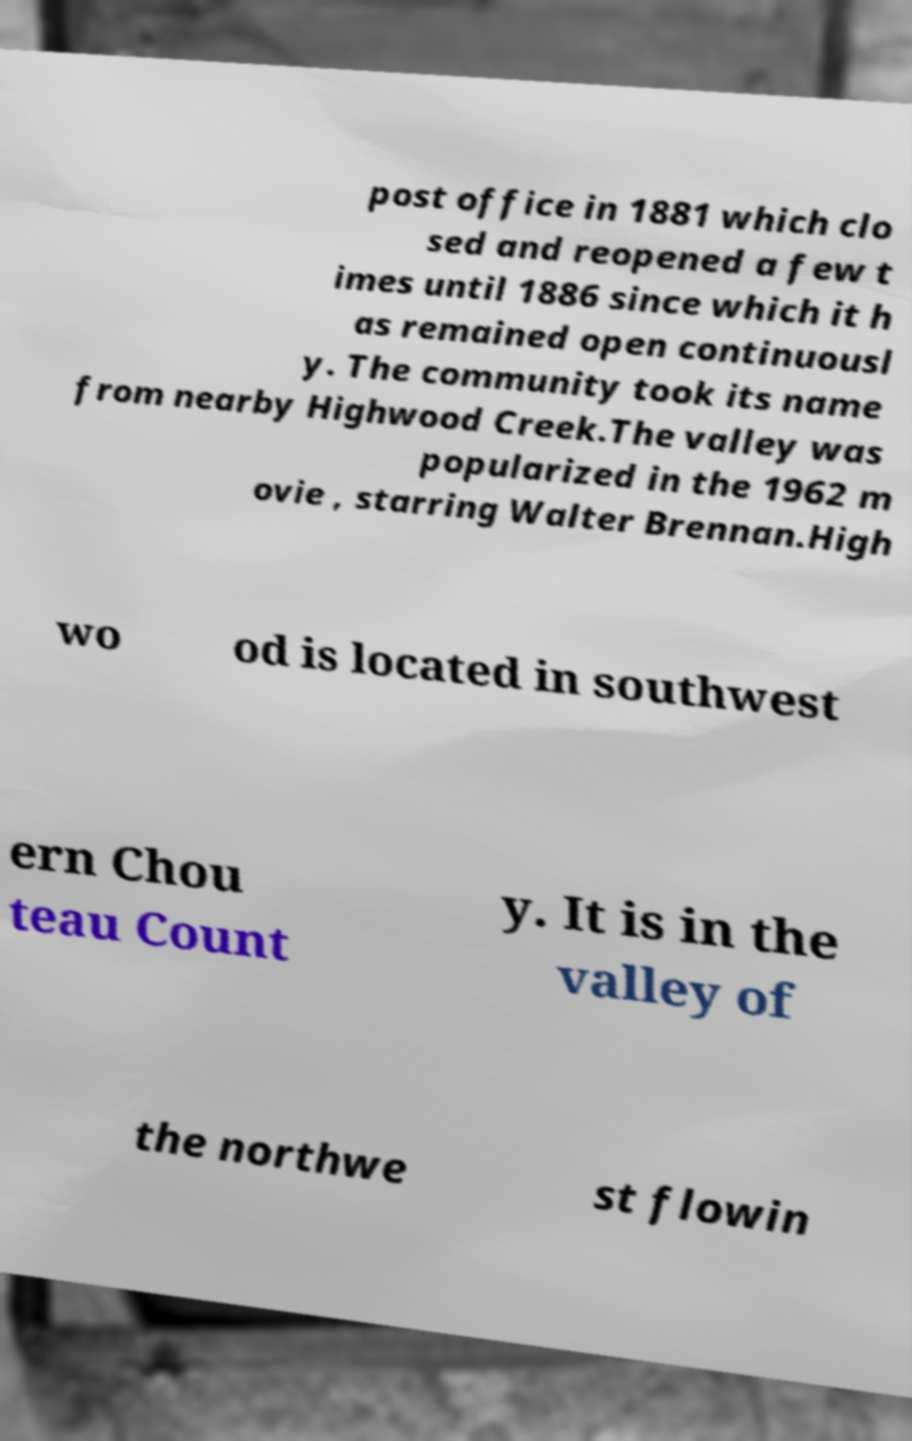What messages or text are displayed in this image? I need them in a readable, typed format. post office in 1881 which clo sed and reopened a few t imes until 1886 since which it h as remained open continuousl y. The community took its name from nearby Highwood Creek.The valley was popularized in the 1962 m ovie , starring Walter Brennan.High wo od is located in southwest ern Chou teau Count y. It is in the valley of the northwe st flowin 